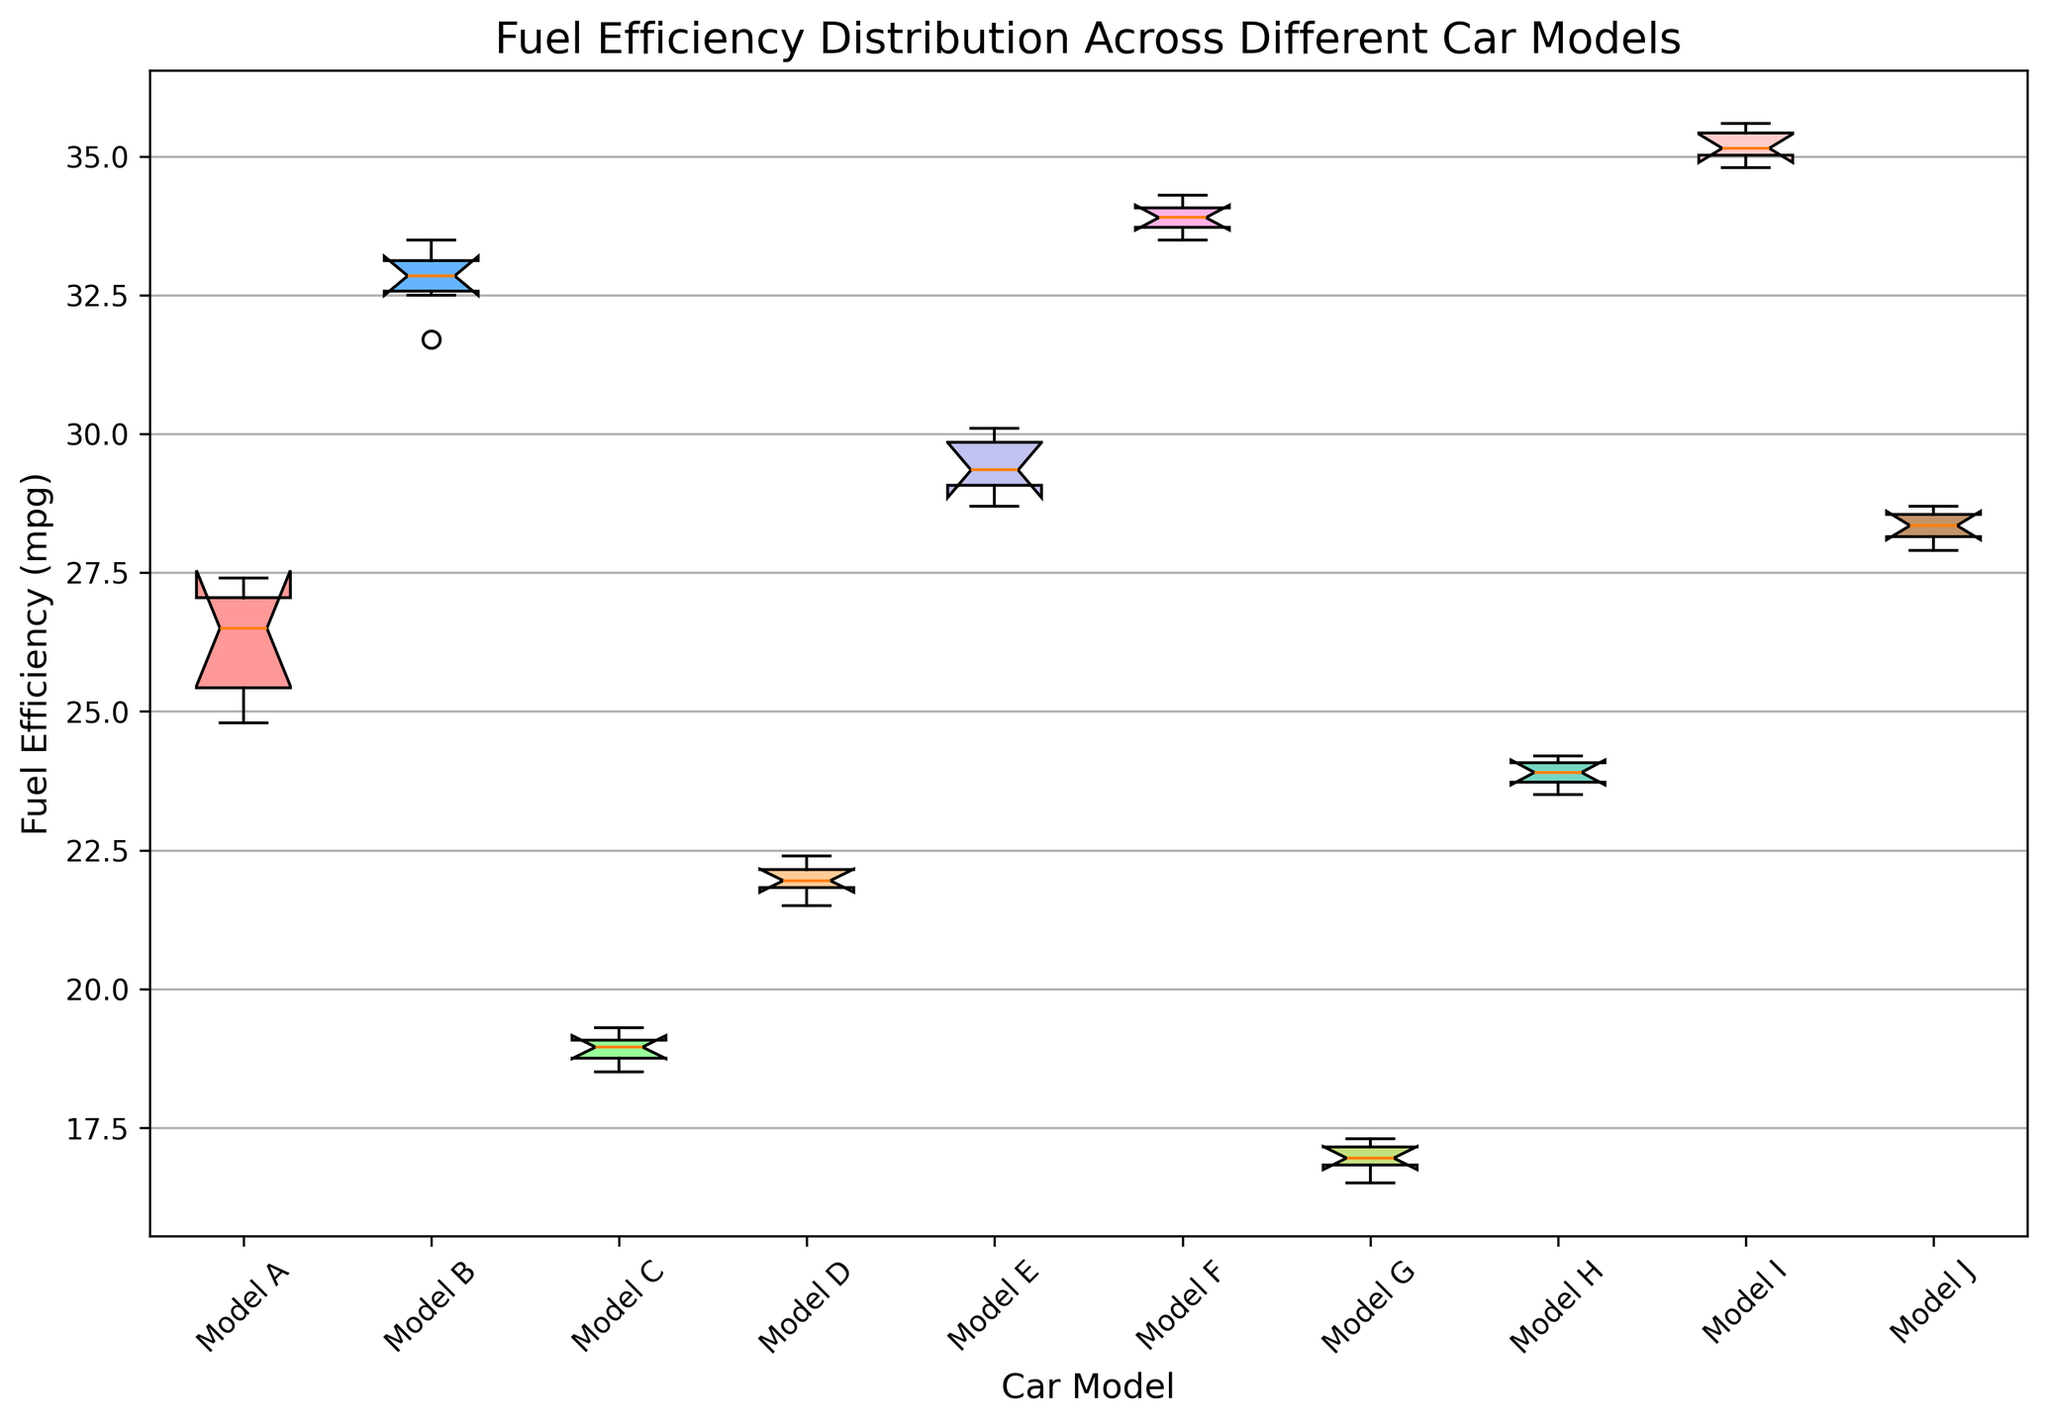Which car model has the highest median fuel efficiency? To determine this, we look at the median lines within each box plot and identify the car model with the highest median line.
Answer: Model I What is the range of fuel efficiency for Model F? The range is found by subtracting the minimum value (bottom whisker of the box) from the maximum value (top whisker of the box) for Model F.
Answer: 0.8 (34.3 - 33.5) Which car models have overlapping interquartile ranges (IQR)? To find this, we visually inspect which boxes (representing IQR) overlap along the y-axis. Models that have overlapping boxes would be the answer.
Answer: Models E and F; Models G and H What is the difference between the median fuel efficiency of Model A and Model I? Find the median values (middle line in the box) of both Model A and Model I and subtract the median of Model A from the median of Model I.
Answer: About 9 Which car model has the smallest variation in fuel efficiency? Variation can be assessed by looking at the height of the box and whiskers. The model with the smallest box and whiskers will have the smallest variation.
Answer: Model F Between Model D and Model H, which one has a higher maximum fuel efficiency? Compare the top whiskers for Model D and Model H and identify which one extends higher.
Answer: Model H Are there any models that have outliers? If yes, which ones? Outliers would be indicated by points outside the whiskers in the box plot. Look for any points that are disconnected from the whiskers.
Answer: No, there are no outliers Which three car models have the lowest median fuel efficiency? Identify the median lines (middle of the boxes) and pick the three lowest ones.
Answer: Models G, C, and D How does the median fuel efficiency of Model B compare to Model J? Compare the median lines (middle of the boxes) of Model B and Model J to see which one is higher.
Answer: Model B is higher What is the interquartile range (IQR) of Model E's fuel efficiency? The IQR is calculated as the difference between the third quartile (top of the box) and the first quartile (bottom of the box) for Model E.
Answer: 1.4 (30.1 - 28.7) 